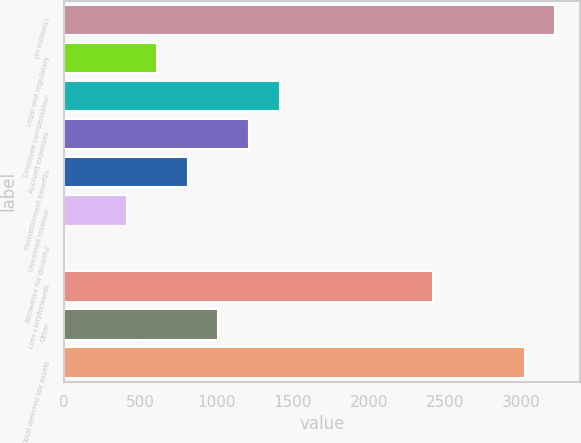Convert chart. <chart><loc_0><loc_0><loc_500><loc_500><bar_chart><fcel>(in millions)<fcel>Legal and regulatory<fcel>Employee compensation<fcel>Accrued expenses<fcel>Postretirement benefits<fcel>Unearned revenue<fcel>Allowance for doubtful<fcel>Loss carryforwards<fcel>Other<fcel>Total deferred tax assets<nl><fcel>3222.4<fcel>610.7<fcel>1414.3<fcel>1213.4<fcel>811.6<fcel>409.8<fcel>8<fcel>2418.8<fcel>1012.5<fcel>3021.5<nl></chart> 